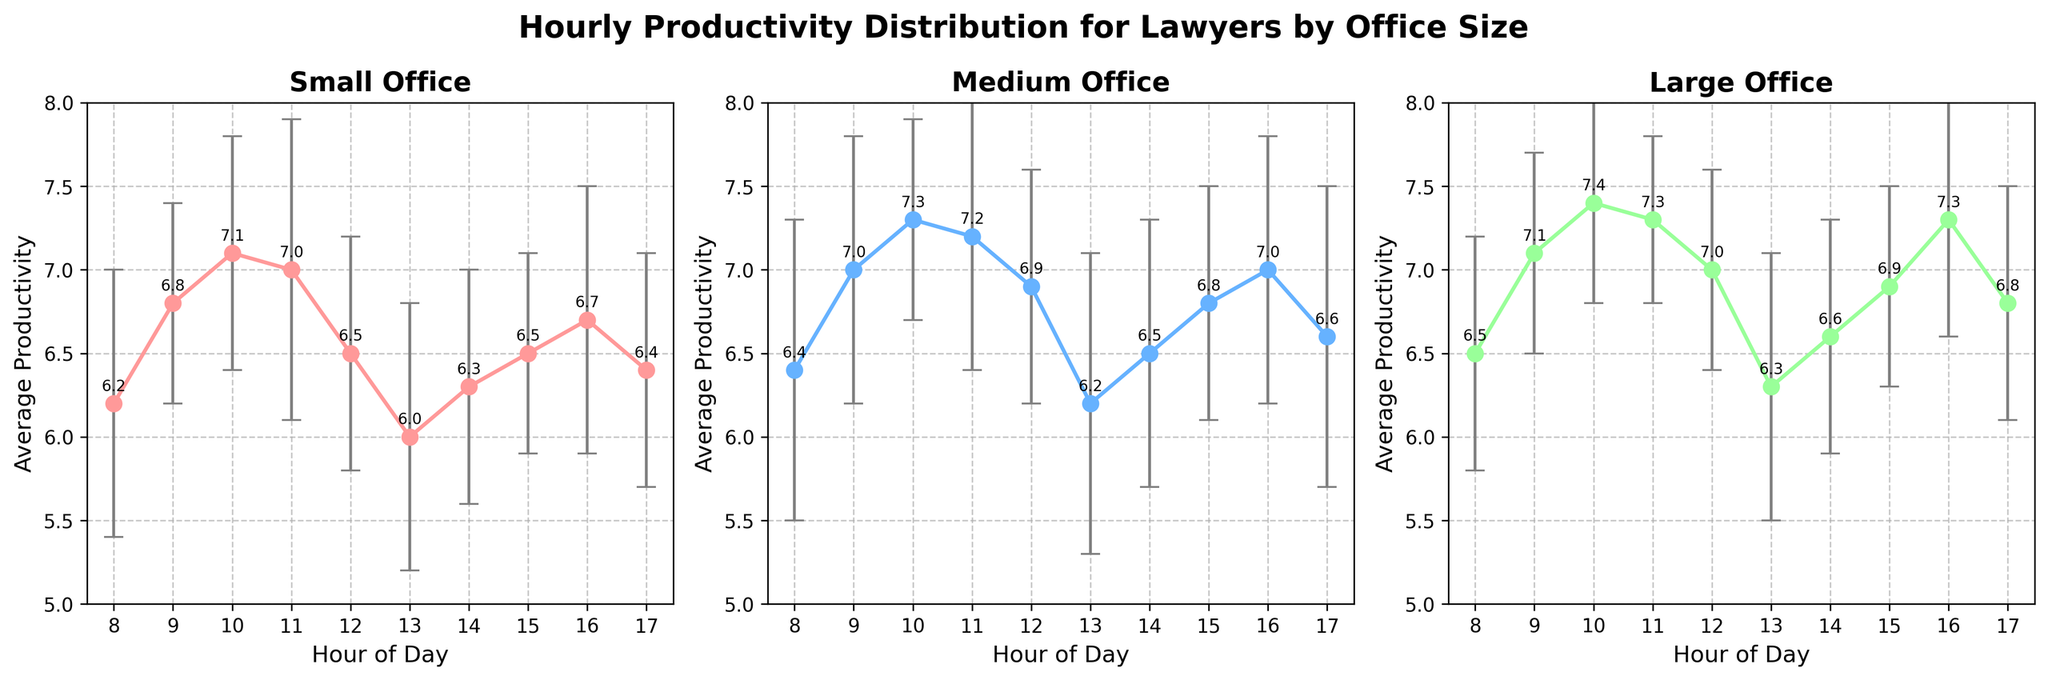What is the title of the figure? The figure's title is prominently displayed at the top. It reads "Hourly Productivity Distribution for Lawyers by Office Size."
Answer: Hourly Productivity Distribution for Lawyers by Office Size How many subplots are in the figure? The figure contains three distinct subplots, each for different office sizes.
Answer: 3 Which hour has the highest average productivity for the Medium office size? In the subplot for the Medium office, the hour with the highest average productivity is represented with a peak. At 10 AM, the productivity is highest at 7.3.
Answer: 10 AM What is the standard deviation of productivity for the Small office at 11 AM? For the Small office size subplot at the 11 AM mark, the error bar indicates a standard deviation of 0.9.
Answer: 0.9 At which hour does the Large office size have both highest average productivity and lowest standard deviation? In the Large office subplot, 10 AM shows the highest average productivity of 7.4 and a lowest standard deviation of 0.6.
Answer: 10 AM What is the range of average productivity for the Small office size from 8 AM to 5 PM? The range is found by subtracting the minimum average productivity from the maximum within the specified time. From 8 AM to 5 PM, the Small office size has a maximum average productivity of 7.1 at 10 AM and a minimum of 6.0 at 1 PM. Thus, the range is 7.1 - 6.0.
Answer: 1.1 Compare the average productivity between Small and Large offices at 9 AM. Which one is higher and by how much? At 9 AM in the Small office, the average productivity is 6.8, while in the Large office, it's 7.1. The difference is 7.1 - 6.8. Hence, the Large office has a higher productivity by 0.3.
Answer: Large, by 0.3 Which office size shows the most consistent productivity over the day considering the standard deviations? The consistency in productivity can be observed by the relative sizes of the error bars. The Large office shows smaller and more consistent error bars throughout the day, indicating the most consistent productivity.
Answer: Large During which hour does the Medium office have less productivity than both Small and Large offices? At 1 PM, the Medium office size shows an average productivity of 6.2, while the Small office is at 6.0 and the Large office is at 6.3. Hence, Medium office has less productivity at 1 PM compared to both.
Answer: 1 PM 